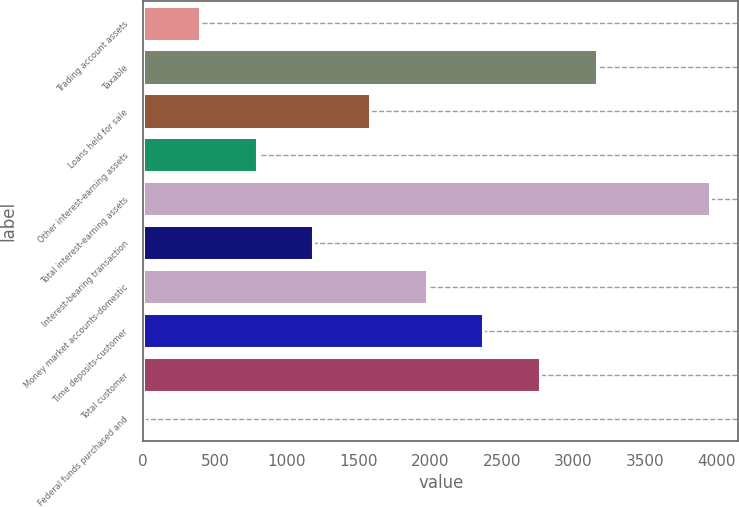Convert chart to OTSL. <chart><loc_0><loc_0><loc_500><loc_500><bar_chart><fcel>Trading account assets<fcel>Taxable<fcel>Loans held for sale<fcel>Other interest-earning assets<fcel>Total interest-earning assets<fcel>Interest-bearing transaction<fcel>Money market accounts-domestic<fcel>Time deposits-customer<fcel>Total customer<fcel>Federal funds purchased and<nl><fcel>397.1<fcel>3162.8<fcel>1582.4<fcel>792.2<fcel>3953<fcel>1187.3<fcel>1977.5<fcel>2372.6<fcel>2767.7<fcel>2<nl></chart> 